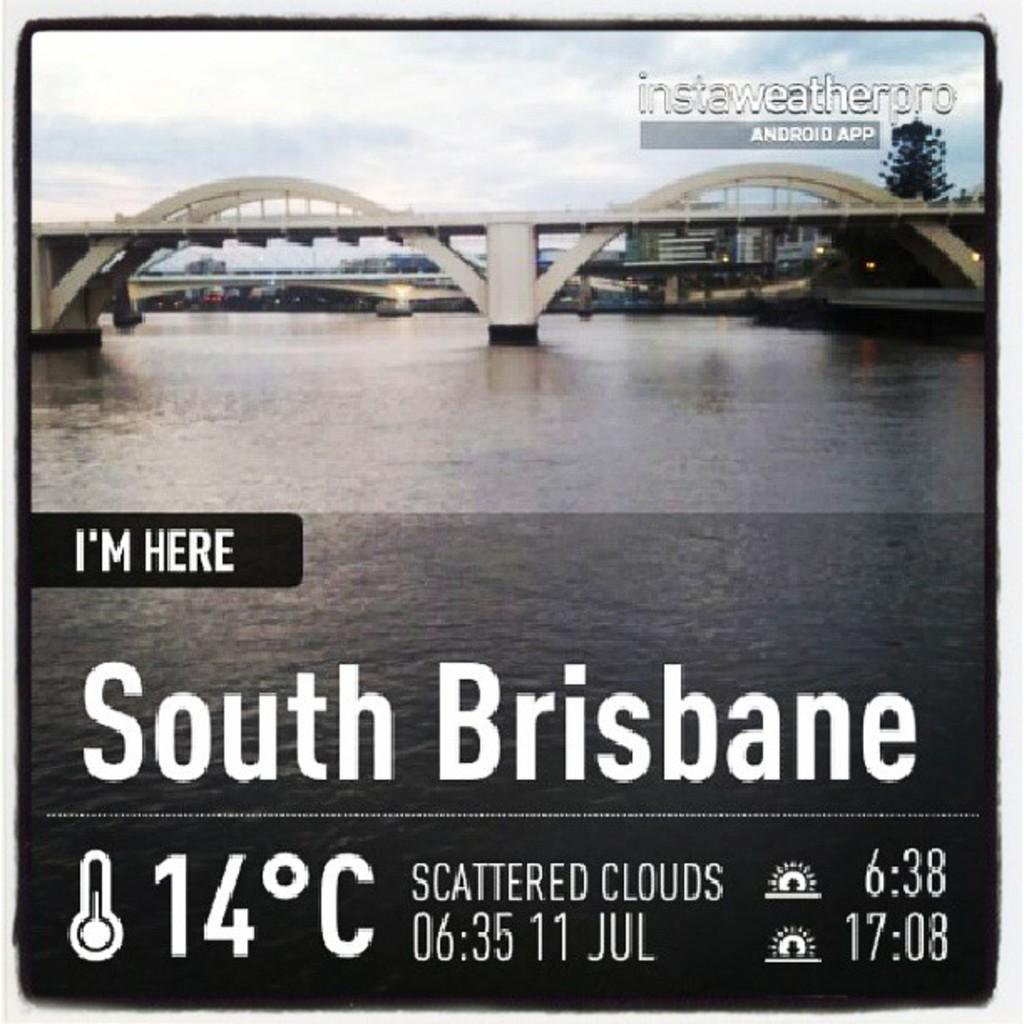<image>
Create a compact narrative representing the image presented. The temperature is currently 14 degrees in South Brisbane. 